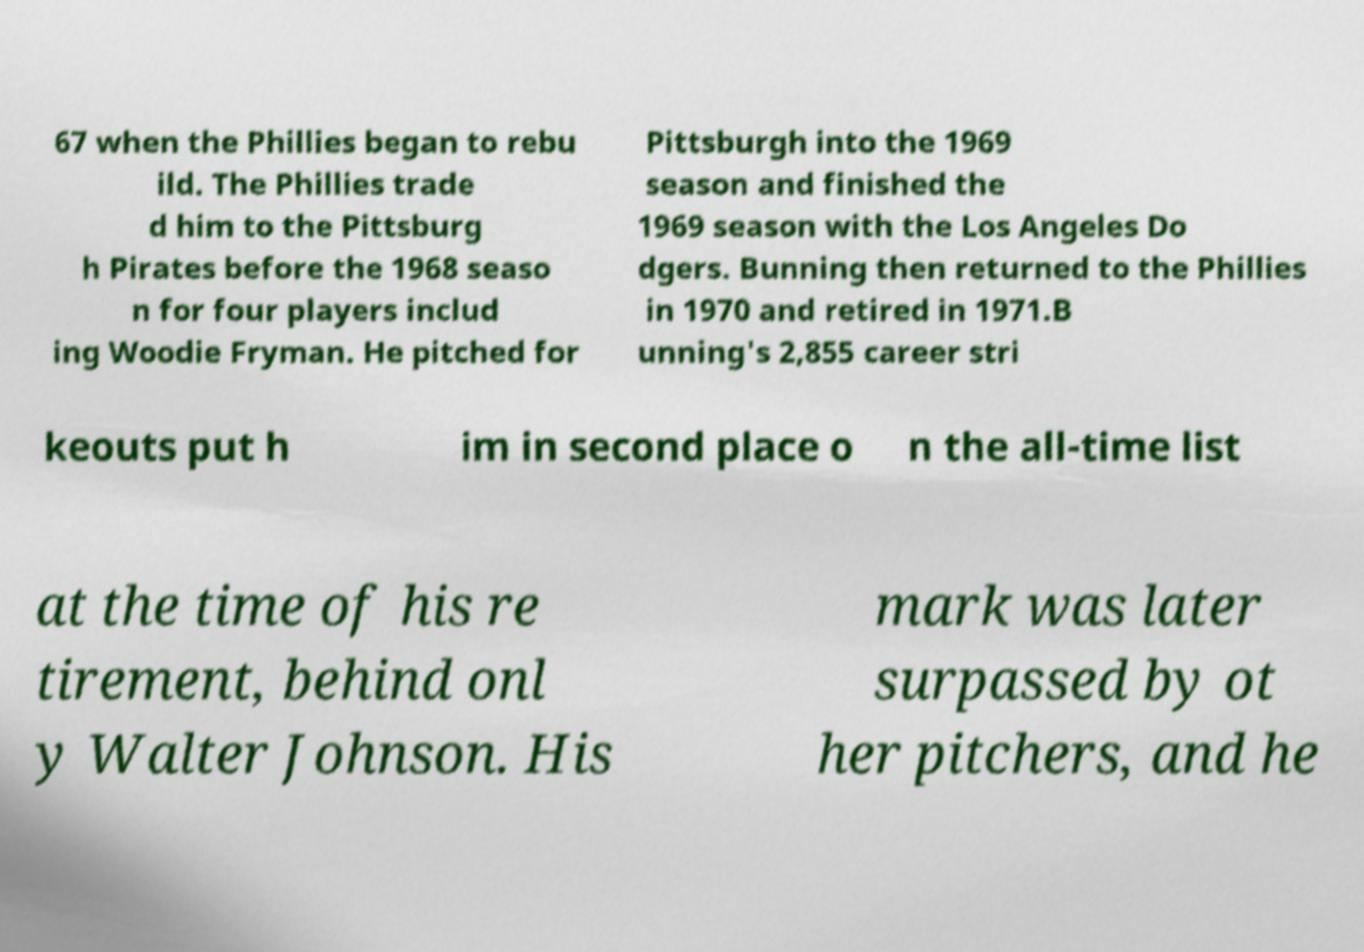Please read and relay the text visible in this image. What does it say? 67 when the Phillies began to rebu ild. The Phillies trade d him to the Pittsburg h Pirates before the 1968 seaso n for four players includ ing Woodie Fryman. He pitched for Pittsburgh into the 1969 season and finished the 1969 season with the Los Angeles Do dgers. Bunning then returned to the Phillies in 1970 and retired in 1971.B unning's 2,855 career stri keouts put h im in second place o n the all-time list at the time of his re tirement, behind onl y Walter Johnson. His mark was later surpassed by ot her pitchers, and he 